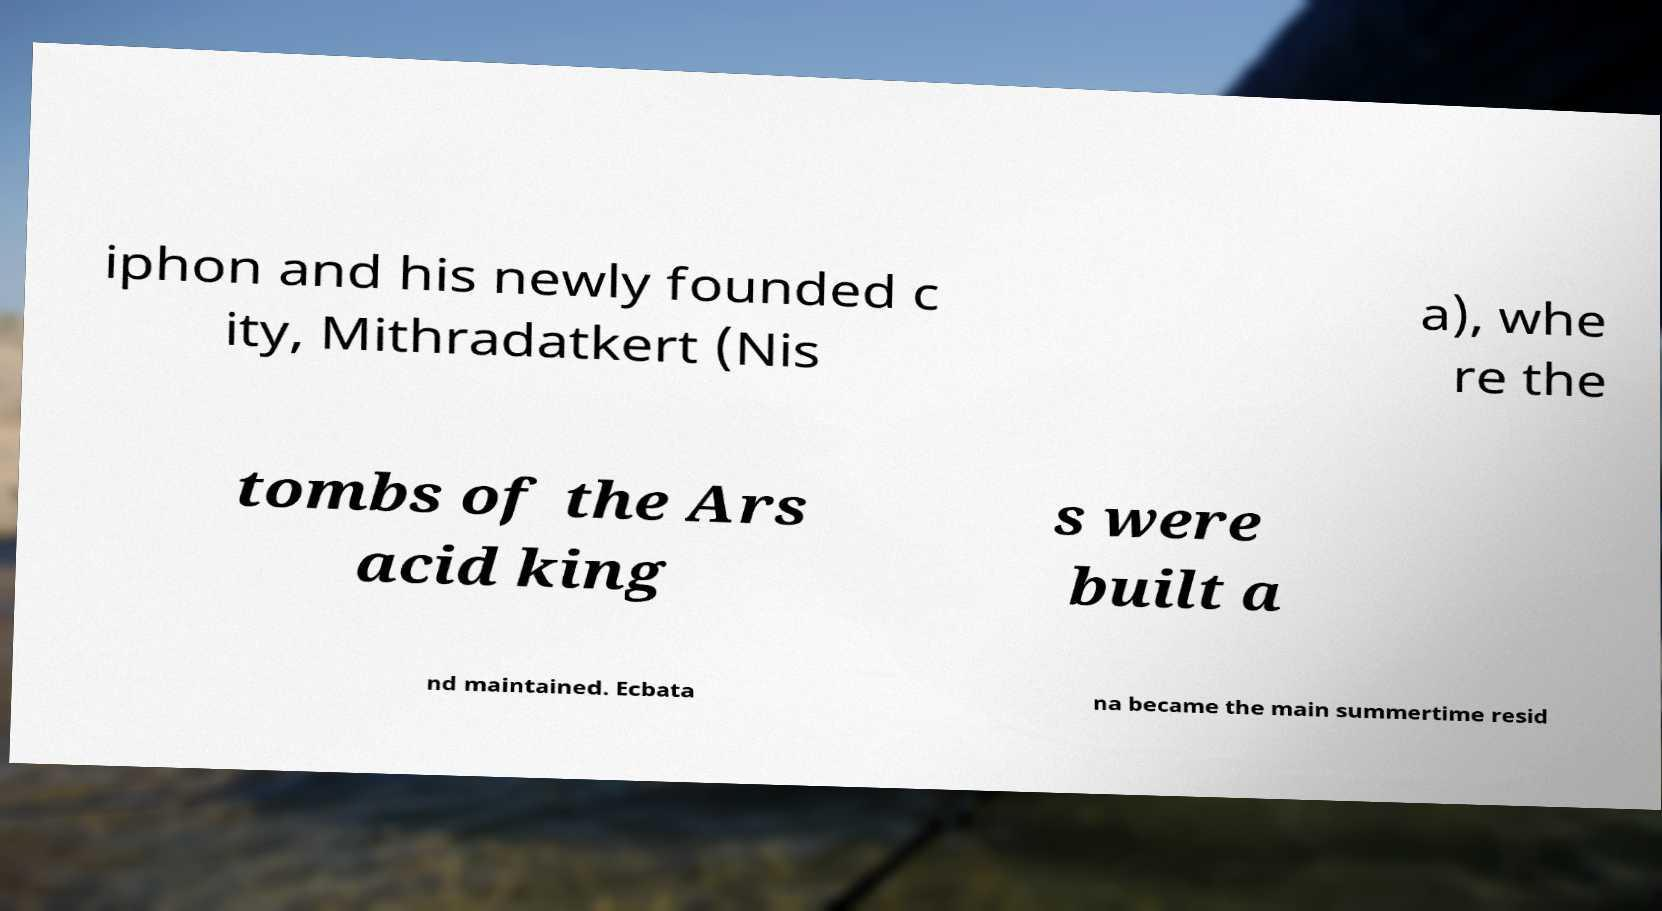Please read and relay the text visible in this image. What does it say? iphon and his newly founded c ity, Mithradatkert (Nis a), whe re the tombs of the Ars acid king s were built a nd maintained. Ecbata na became the main summertime resid 